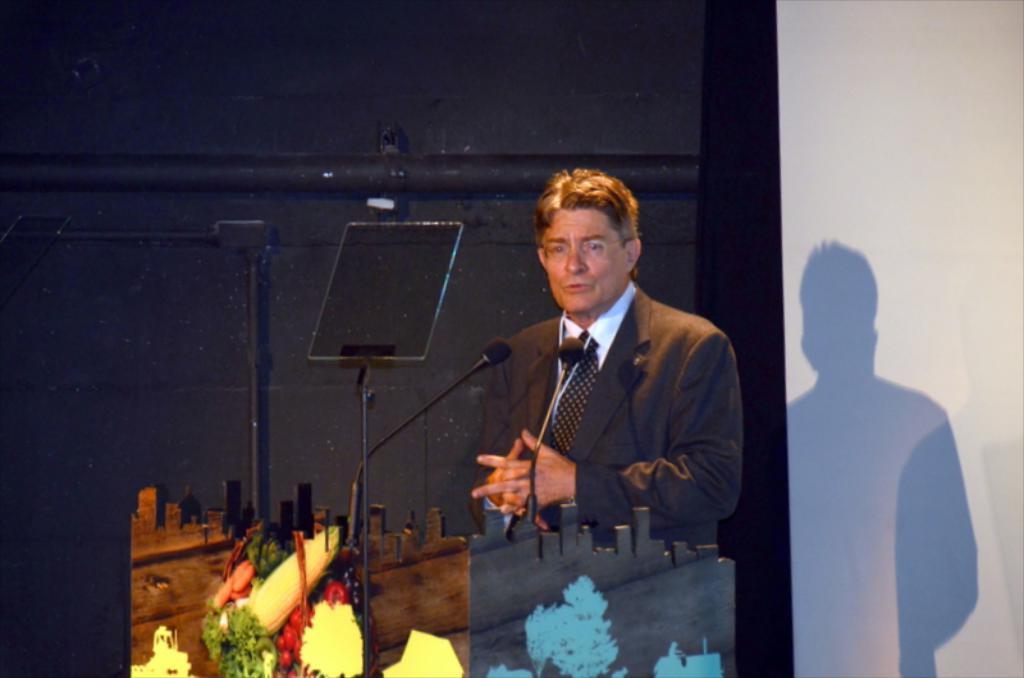Describe this image in one or two sentences. The picture is taken from a conference. In the foreground of the picture there are podium, mic, stand, camera and a person in black suit. Towards left there is a black wall. Towards the right it is wall painted white. 